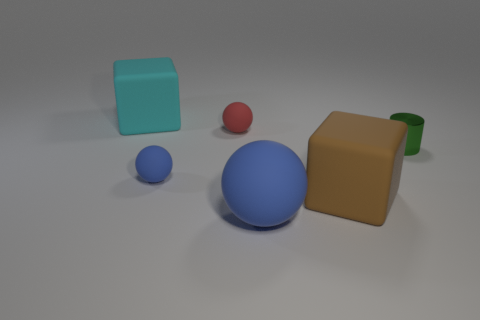Subtract all big blue spheres. How many spheres are left? 2 Subtract all purple blocks. How many blue balls are left? 2 Subtract 1 spheres. How many spheres are left? 2 Add 2 big cyan objects. How many objects exist? 8 Subtract all cylinders. How many objects are left? 5 Add 4 tiny balls. How many tiny balls exist? 6 Subtract 0 brown cylinders. How many objects are left? 6 Subtract all cylinders. Subtract all small spheres. How many objects are left? 3 Add 3 green shiny objects. How many green shiny objects are left? 4 